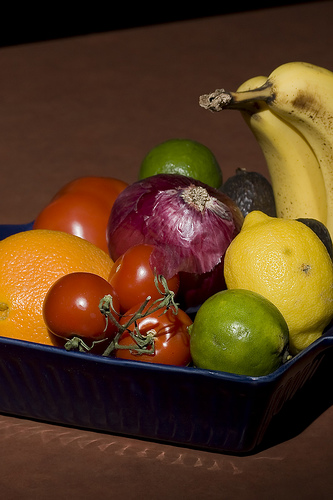<image>
Is the onion next to the tomatoe? Yes. The onion is positioned adjacent to the tomatoe, located nearby in the same general area. 